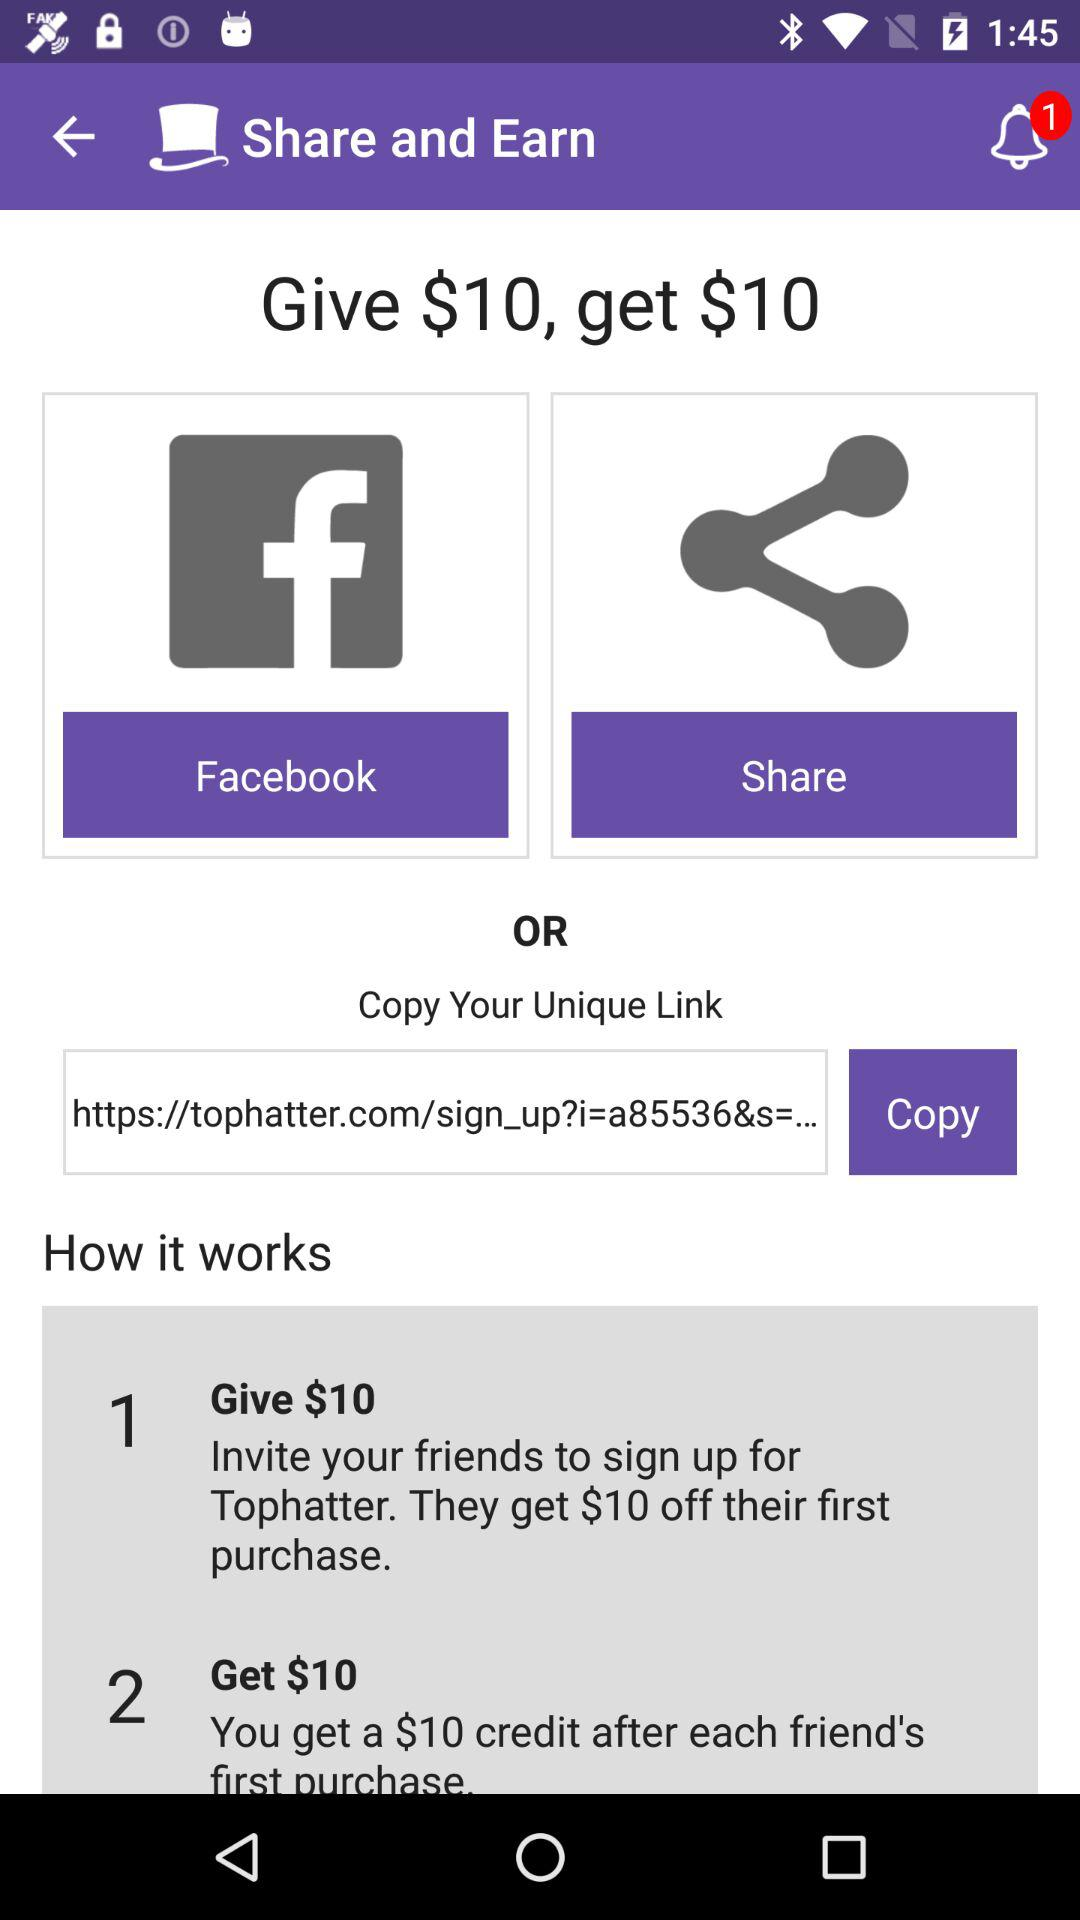How much credit do we get after each friend's first purchase? You get a $10 credit after each friend's first purchase. 